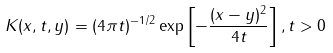<formula> <loc_0><loc_0><loc_500><loc_500>K ( x , t , y ) = ( 4 \pi t ) ^ { - 1 / 2 } \exp \left [ - \frac { ( x - y ) ^ { 2 } } { 4 t } \right ] , t > 0</formula> 